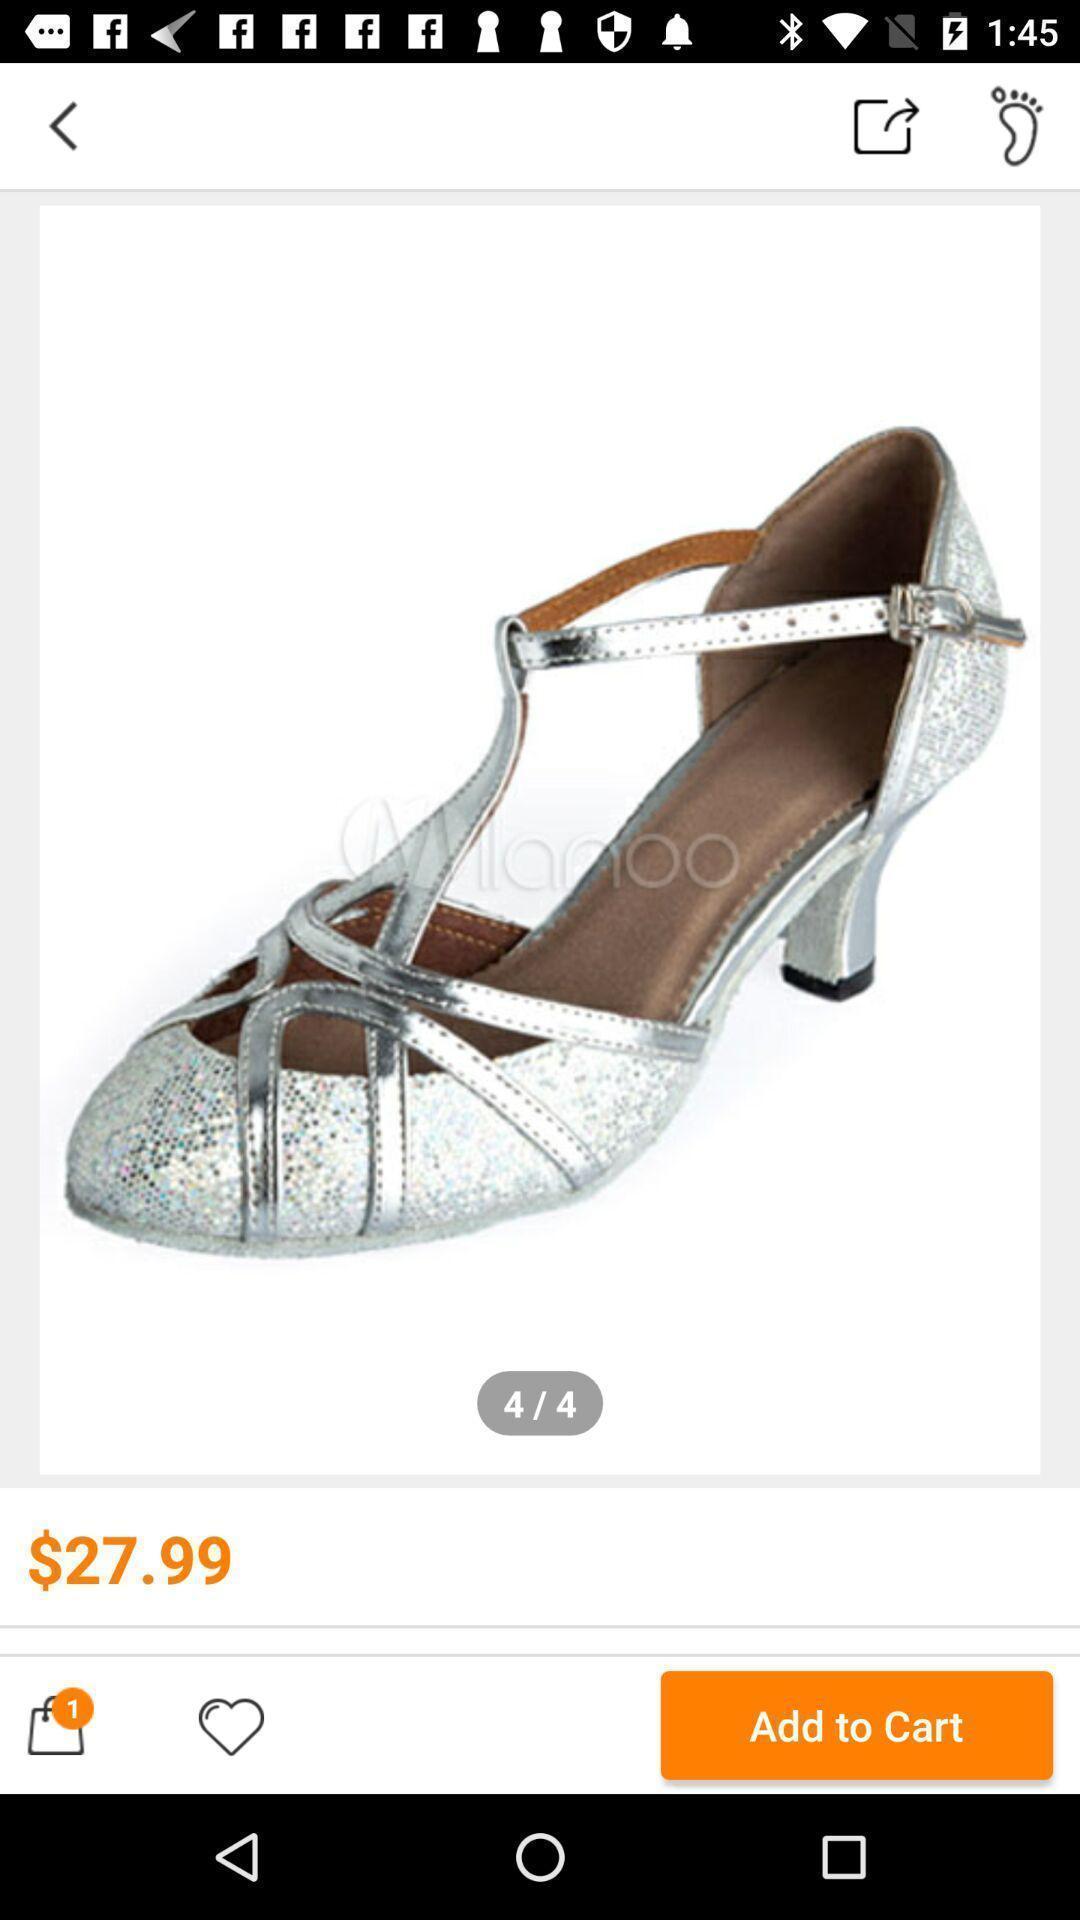Give me a summary of this screen capture. Page displaying the product and price in a shopping app. 